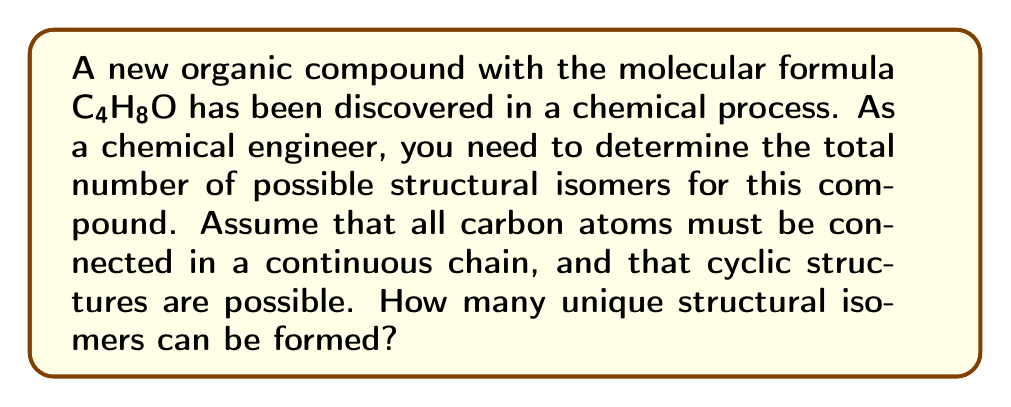Solve this math problem. To solve this problem, we'll follow these steps:

1) First, let's consider the possible carbon skeletons:
   - Linear chain: C-C-C-C
   - Branched chain: C-C(C)-C
   - Cyclic: C-C-C-C (in a ring)

2) For each carbon skeleton, we need to consider the possible positions of the oxygen atom:

   a) Linear chain:
      - O can be attached to any of the 4 carbon atoms
      - O can form a carbonyl group (C=O) at any of the 4 positions
      Total for linear: $4 + 4 = 8$

   b) Branched chain:
      - O can be attached to any of the 4 carbon atoms
      - O can form a carbonyl group at any of the 4 positions
      Total for branched: $4 + 4 = 8$

   c) Cyclic:
      - O can be attached to any of the 4 carbon atoms (all equivalent due to symmetry)
      - O can form a carbonyl group at any of the 4 positions (all equivalent)
      Total for cyclic: $1 + 1 = 2$

3) Now, let's count the isomers for each case:

   a) Linear chain:
      - Butanol: 4 isomers (1-butanol, 2-butanol, isobutanol, tert-butanol)
      - Butanal: 1 isomer
      - Butanone: 2 isomers (2-butanone, 3-butanone)
      - Ethoxyethane: 1 isomer
      Total linear: $4 + 1 + 2 + 1 = 8$

   b) Branched chain:
      - 2-Methylpropanol: 1 isomer
      - 2-Methylpropanal: 1 isomer
      - Methyl isopropyl ether: 1 isomer
      Total branched: $1 + 1 + 1 = 3$

   c) Cyclic:
      - Cyclobutanol: 1 isomer
      - Cyclobutanone: 1 isomer
      Total cyclic: $1 + 1 = 2$

4) The total number of unique structural isomers is the sum of all possible structures:

   $$ \text{Total isomers} = 8 + 3 + 2 = 13 $$

Therefore, there are 13 unique structural isomers for the compound C₄H₈O.
Answer: 13 